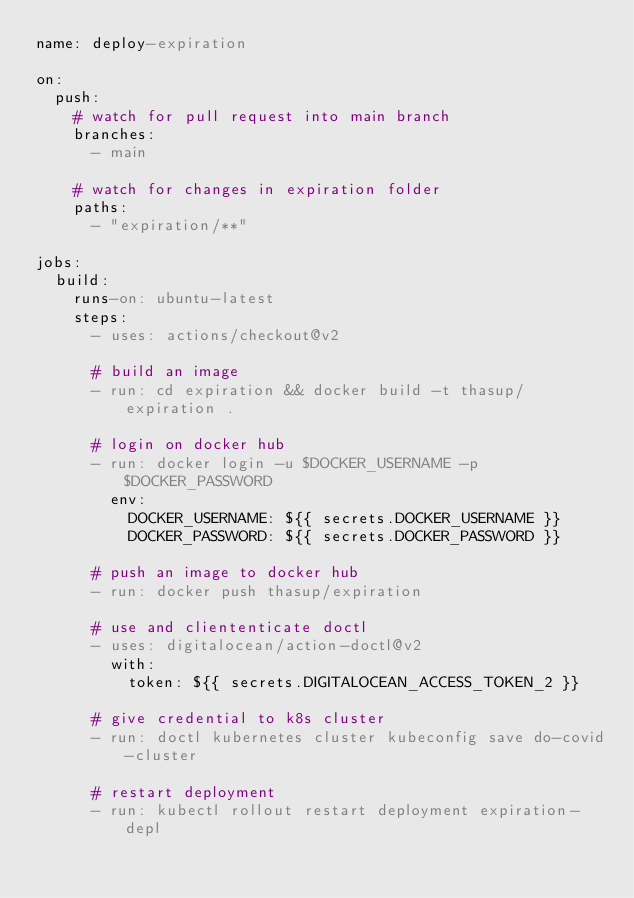Convert code to text. <code><loc_0><loc_0><loc_500><loc_500><_YAML_>name: deploy-expiration

on:
  push:
    # watch for pull request into main branch
    branches:
      - main

    # watch for changes in expiration folder
    paths:
      - "expiration/**"

jobs:
  build:
    runs-on: ubuntu-latest
    steps:
      - uses: actions/checkout@v2

      # build an image
      - run: cd expiration && docker build -t thasup/expiration .

      # login on docker hub
      - run: docker login -u $DOCKER_USERNAME -p $DOCKER_PASSWORD
        env:
          DOCKER_USERNAME: ${{ secrets.DOCKER_USERNAME }}
          DOCKER_PASSWORD: ${{ secrets.DOCKER_PASSWORD }}

      # push an image to docker hub
      - run: docker push thasup/expiration

      # use and cliententicate doctl
      - uses: digitalocean/action-doctl@v2
        with:
          token: ${{ secrets.DIGITALOCEAN_ACCESS_TOKEN_2 }}

      # give credential to k8s cluster
      - run: doctl kubernetes cluster kubeconfig save do-covid-cluster

      # restart deployment
      - run: kubectl rollout restart deployment expiration-depl
</code> 